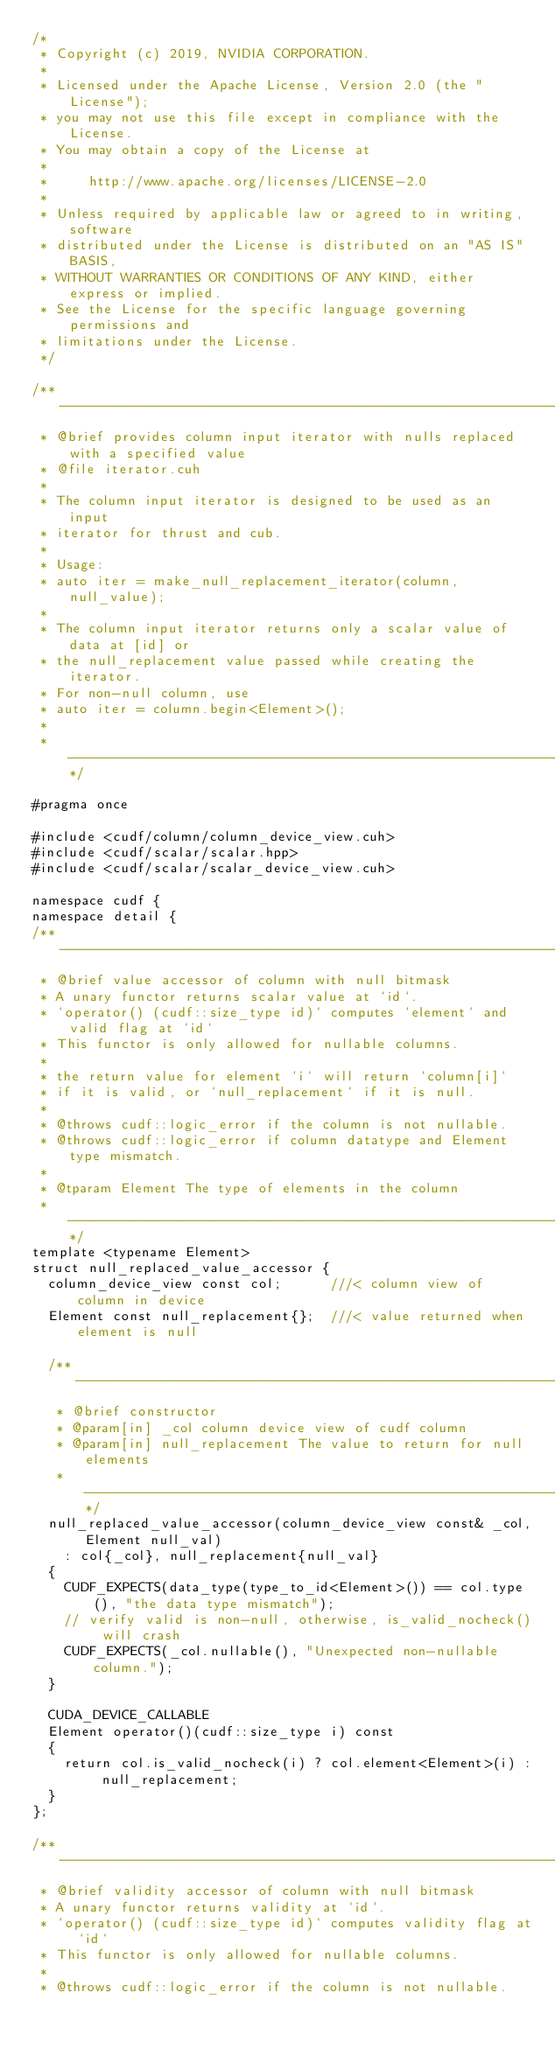<code> <loc_0><loc_0><loc_500><loc_500><_Cuda_>/*
 * Copyright (c) 2019, NVIDIA CORPORATION.
 *
 * Licensed under the Apache License, Version 2.0 (the "License");
 * you may not use this file except in compliance with the License.
 * You may obtain a copy of the License at
 *
 *     http://www.apache.org/licenses/LICENSE-2.0
 *
 * Unless required by applicable law or agreed to in writing, software
 * distributed under the License is distributed on an "AS IS" BASIS,
 * WITHOUT WARRANTIES OR CONDITIONS OF ANY KIND, either express or implied.
 * See the License for the specific language governing permissions and
 * limitations under the License.
 */

/** --------------------------------------------------------------------------*
 * @brief provides column input iterator with nulls replaced with a specified value
 * @file iterator.cuh
 *
 * The column input iterator is designed to be used as an input
 * iterator for thrust and cub.
 *
 * Usage:
 * auto iter = make_null_replacement_iterator(column, null_value);
 *
 * The column input iterator returns only a scalar value of data at [id] or
 * the null_replacement value passed while creating the iterator.
 * For non-null column, use
 * auto iter = column.begin<Element>();
 *
 * -------------------------------------------------------------------------**/

#pragma once

#include <cudf/column/column_device_view.cuh>
#include <cudf/scalar/scalar.hpp>
#include <cudf/scalar/scalar_device_view.cuh>

namespace cudf {
namespace detail {
/** -------------------------------------------------------------------------*
 * @brief value accessor of column with null bitmask
 * A unary functor returns scalar value at `id`.
 * `operator() (cudf::size_type id)` computes `element` and valid flag at `id`
 * This functor is only allowed for nullable columns.
 *
 * the return value for element `i` will return `column[i]`
 * if it is valid, or `null_replacement` if it is null.
 *
 * @throws cudf::logic_error if the column is not nullable.
 * @throws cudf::logic_error if column datatype and Element type mismatch.
 *
 * @tparam Element The type of elements in the column
 * -------------------------------------------------------------------------**/
template <typename Element>
struct null_replaced_value_accessor {
  column_device_view const col;      ///< column view of column in device
  Element const null_replacement{};  ///< value returned when element is null

  /** -------------------------------------------------------------------------*
   * @brief constructor
   * @param[in] _col column device view of cudf column
   * @param[in] null_replacement The value to return for null elements
   * -------------------------------------------------------------------------**/
  null_replaced_value_accessor(column_device_view const& _col, Element null_val)
    : col{_col}, null_replacement{null_val}
  {
    CUDF_EXPECTS(data_type(type_to_id<Element>()) == col.type(), "the data type mismatch");
    // verify valid is non-null, otherwise, is_valid_nocheck() will crash
    CUDF_EXPECTS(_col.nullable(), "Unexpected non-nullable column.");
  }

  CUDA_DEVICE_CALLABLE
  Element operator()(cudf::size_type i) const
  {
    return col.is_valid_nocheck(i) ? col.element<Element>(i) : null_replacement;
  }
};

/** -------------------------------------------------------------------------*
 * @brief validity accessor of column with null bitmask
 * A unary functor returns validity at `id`.
 * `operator() (cudf::size_type id)` computes validity flag at `id`
 * This functor is only allowed for nullable columns.
 *
 * @throws cudf::logic_error if the column is not nullable.</code> 